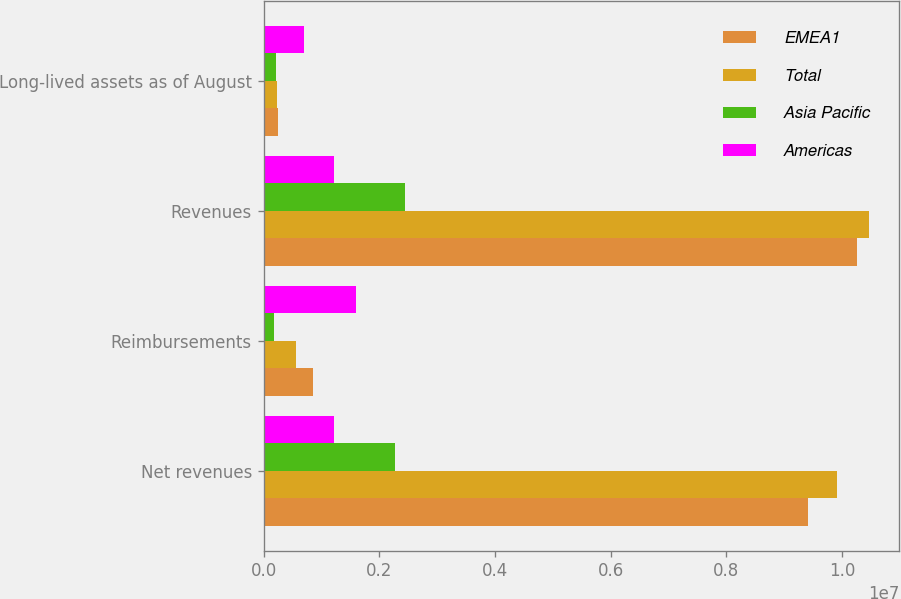<chart> <loc_0><loc_0><loc_500><loc_500><stacked_bar_chart><ecel><fcel>Net revenues<fcel>Reimbursements<fcel>Revenues<fcel>Long-lived assets as of August<nl><fcel>EMEA1<fcel>9.40342e+06<fcel>853035<fcel>1.02565e+07<fcel>254922<nl><fcel>Total<fcel>9.90354e+06<fcel>564886<fcel>1.04684e+07<fcel>237845<nl><fcel>Asia Pacific<fcel>2.26989e+06<fcel>176197<fcel>2.44609e+06<fcel>208377<nl><fcel>Americas<fcel>1.22358e+06<fcel>1.59412e+06<fcel>1.22358e+06<fcel>701144<nl></chart> 